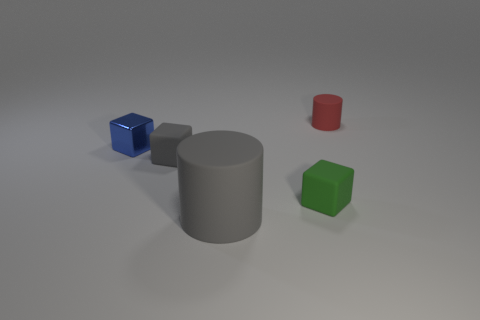Can you describe the material and appearance of the blue object? The blue object appears to be a cube with a shiny, possibly metallic surface, reflecting light and giving it a polished look. 